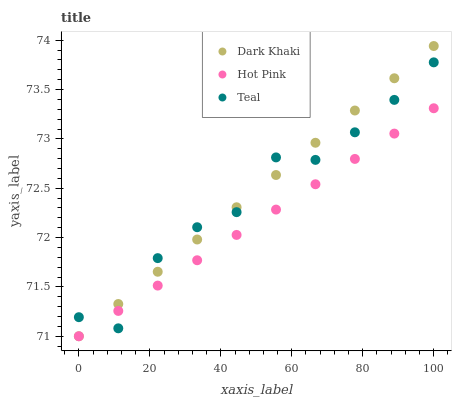Does Hot Pink have the minimum area under the curve?
Answer yes or no. Yes. Does Dark Khaki have the maximum area under the curve?
Answer yes or no. Yes. Does Teal have the minimum area under the curve?
Answer yes or no. No. Does Teal have the maximum area under the curve?
Answer yes or no. No. Is Dark Khaki the smoothest?
Answer yes or no. Yes. Is Teal the roughest?
Answer yes or no. Yes. Is Hot Pink the smoothest?
Answer yes or no. No. Is Hot Pink the roughest?
Answer yes or no. No. Does Dark Khaki have the lowest value?
Answer yes or no. Yes. Does Teal have the lowest value?
Answer yes or no. No. Does Dark Khaki have the highest value?
Answer yes or no. Yes. Does Teal have the highest value?
Answer yes or no. No. Does Teal intersect Hot Pink?
Answer yes or no. Yes. Is Teal less than Hot Pink?
Answer yes or no. No. Is Teal greater than Hot Pink?
Answer yes or no. No. 